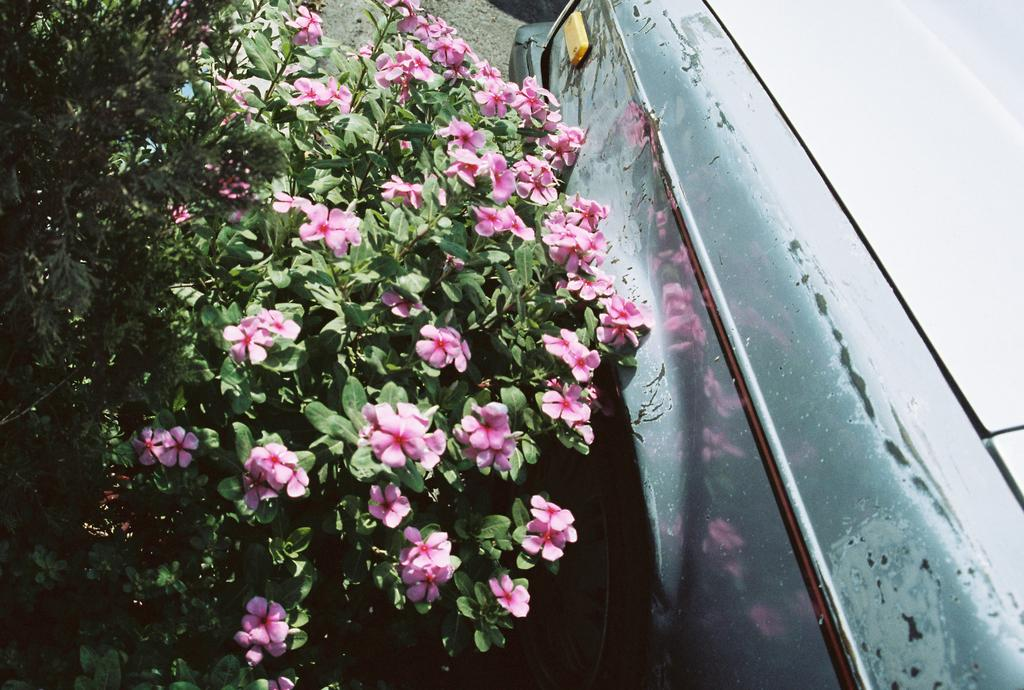What type of living organisms can be seen in the image? There are flowers and plants in the image. Can you describe the vehicle in the image? There is a vehicle in the image, but its specific type is not mentioned. What other objects or features can be seen in the image? The facts provided do not mention any other objects or features in the image. What type of neck accessory is the camera wearing in the image? There is no camera or neck accessory present in the image. 